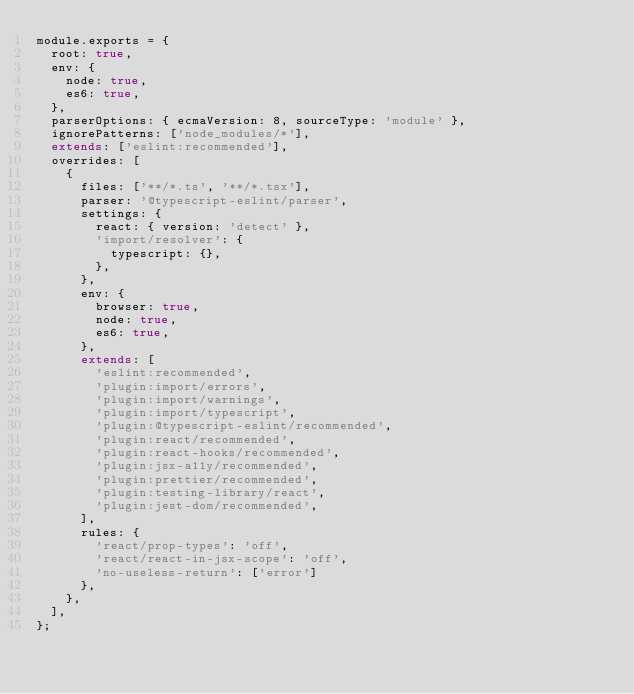<code> <loc_0><loc_0><loc_500><loc_500><_JavaScript_>module.exports = {
  root: true,
  env: {
    node: true,
    es6: true,
  },
  parserOptions: { ecmaVersion: 8, sourceType: 'module' },
  ignorePatterns: ['node_modules/*'],
  extends: ['eslint:recommended'],
  overrides: [
    {
      files: ['**/*.ts', '**/*.tsx'],
      parser: '@typescript-eslint/parser',
      settings: {
        react: { version: 'detect' },
        'import/resolver': {
          typescript: {},
        },
      },
      env: {
        browser: true,
        node: true,
        es6: true,
      },
      extends: [
        'eslint:recommended',
        'plugin:import/errors',
        'plugin:import/warnings',
        'plugin:import/typescript',
        'plugin:@typescript-eslint/recommended',
        'plugin:react/recommended',
        'plugin:react-hooks/recommended',
        'plugin:jsx-a11y/recommended',
        'plugin:prettier/recommended',
        'plugin:testing-library/react',
        'plugin:jest-dom/recommended',
      ],
      rules: {
        'react/prop-types': 'off',
        'react/react-in-jsx-scope': 'off',
        'no-useless-return': ['error']
      },
    },
  ],
};
</code> 